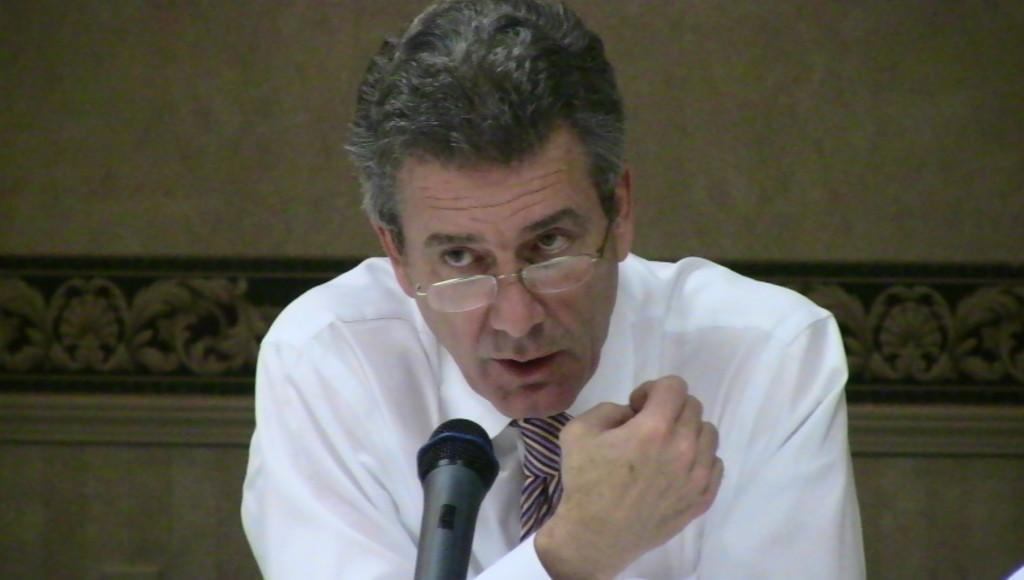Who is present in the image? There is a man in the image. What is the man wearing on his face? The man is wearing spectacles. What is the man wearing on his upper body? The man is wearing a white shirt. What object is in front of the man? There is a microphone in front of the man. What is behind the man in the image? There is a wall behind the man. Can you see a kitty playing with regret in the image? There is no kitty or emotion like regret present in the image. 